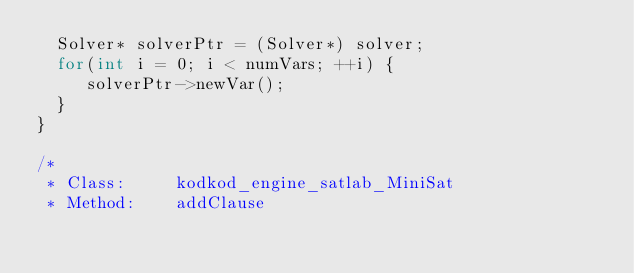Convert code to text. <code><loc_0><loc_0><loc_500><loc_500><_C++_>  Solver* solverPtr = (Solver*) solver;
  for(int i = 0; i < numVars; ++i) {
     solverPtr->newVar();
  }
}

/*
 * Class:     kodkod_engine_satlab_MiniSat
 * Method:    addClause</code> 